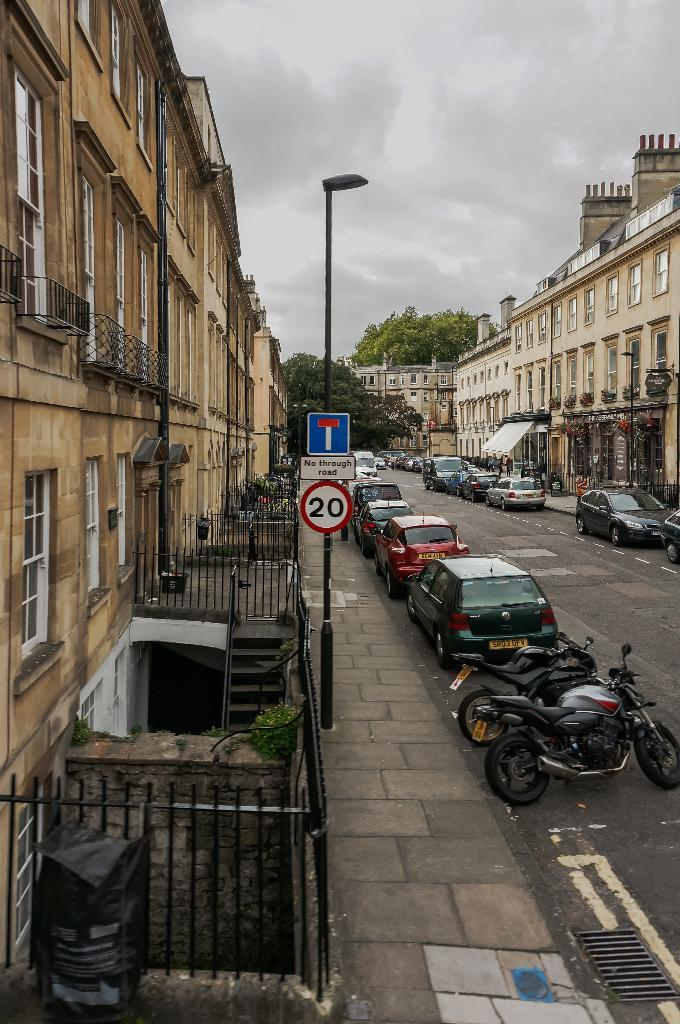What can be seen on the road in the image? There are vehicles on the road in the image. What is visible in the background of the image? There are buildings, trees, and poles in the background of the image. What is visible at the top of the image? The sky is visible at the top of the image. Can you see anyone swimming in the coast in the image? There is no coast or swimming activity present in the image; it features vehicles on a road with buildings, trees, and poles in the background. What type of flame can be seen coming from the buildings in the image? There are no flames present in the image; it features vehicles on a road with buildings, trees, and poles in the background. 